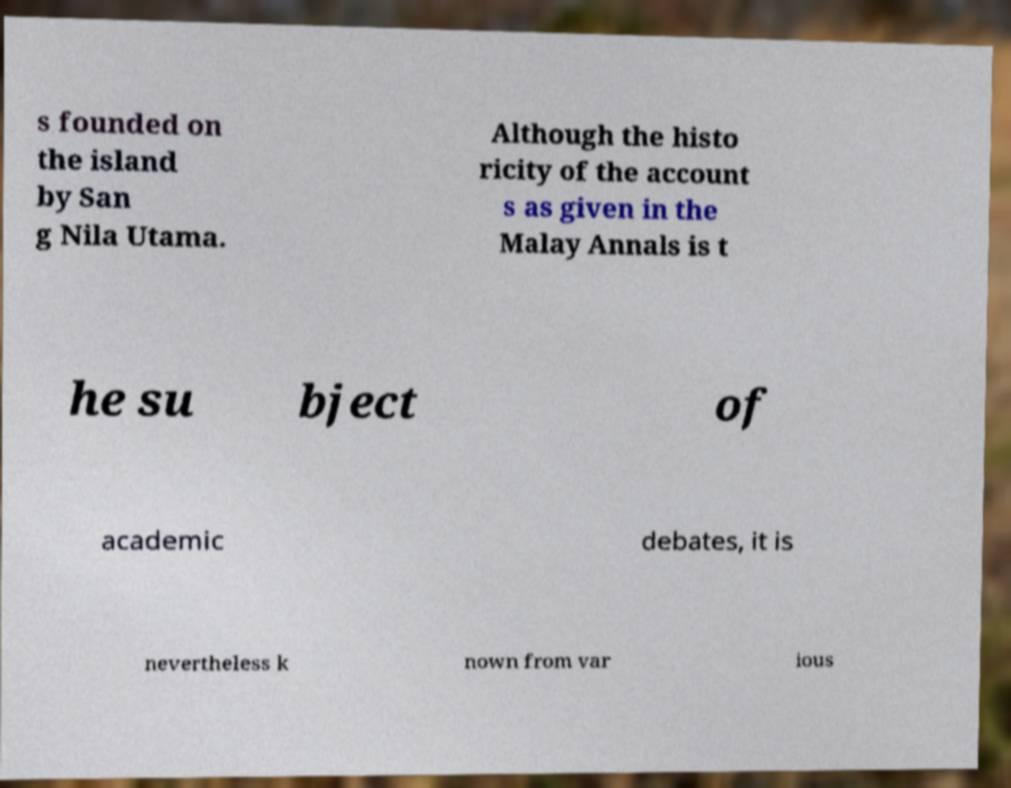For documentation purposes, I need the text within this image transcribed. Could you provide that? s founded on the island by San g Nila Utama. Although the histo ricity of the account s as given in the Malay Annals is t he su bject of academic debates, it is nevertheless k nown from var ious 